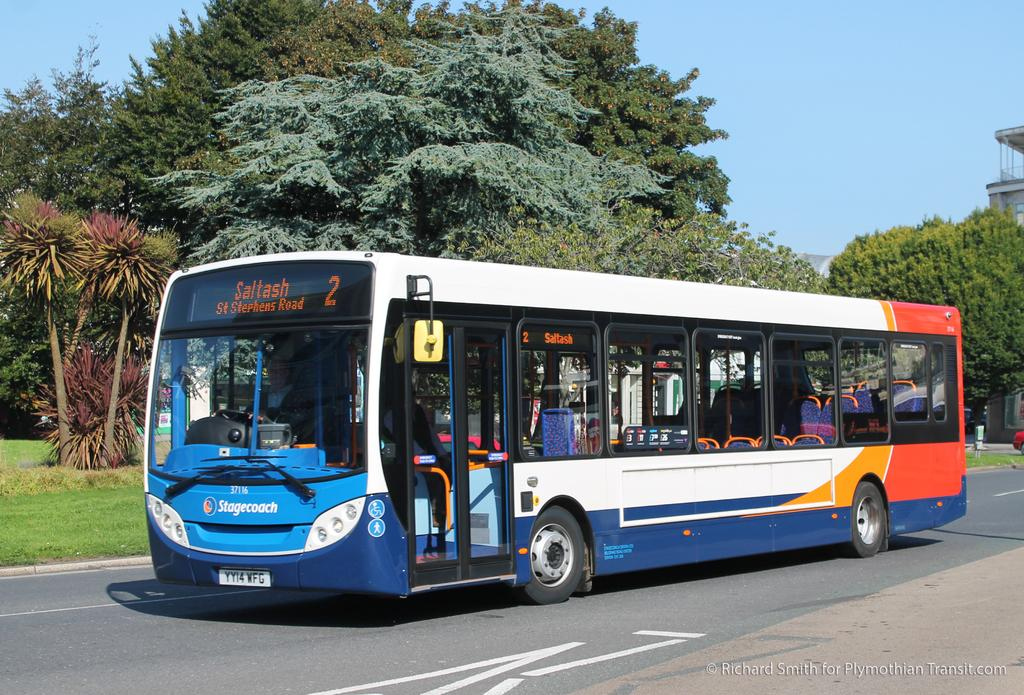<image>
Write a terse but informative summary of the picture. a colorful public bus for Saltash ST Stephens Road number 2 